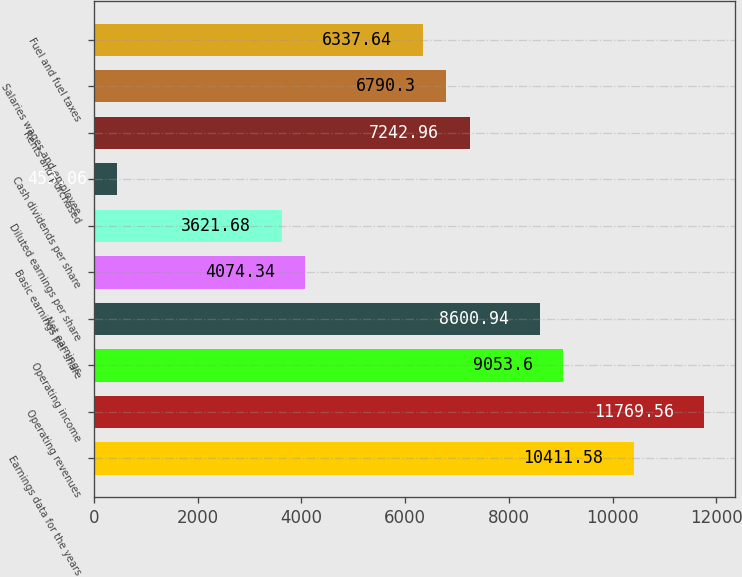Convert chart. <chart><loc_0><loc_0><loc_500><loc_500><bar_chart><fcel>Earnings data for the years<fcel>Operating revenues<fcel>Operating income<fcel>Net earnings<fcel>Basic earnings per share<fcel>Diluted earnings per share<fcel>Cash dividends per share<fcel>Rents and purchased<fcel>Salaries wages and employee<fcel>Fuel and fuel taxes<nl><fcel>10411.6<fcel>11769.6<fcel>9053.6<fcel>8600.94<fcel>4074.34<fcel>3621.68<fcel>453.06<fcel>7242.96<fcel>6790.3<fcel>6337.64<nl></chart> 